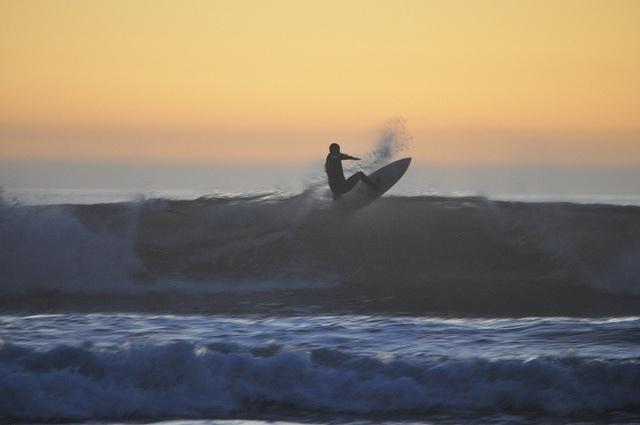Describe the objects in this image and their specific colors. I can see surfboard in tan, black, and purple tones and people in tan, black, gray, and darkgray tones in this image. 